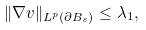Convert formula to latex. <formula><loc_0><loc_0><loc_500><loc_500>\| \nabla v \| _ { L ^ { p } ( \partial B _ { s } ) } \leq \lambda _ { 1 } ,</formula> 